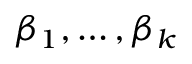<formula> <loc_0><loc_0><loc_500><loc_500>\beta _ { 1 } , \dots , \beta _ { k }</formula> 